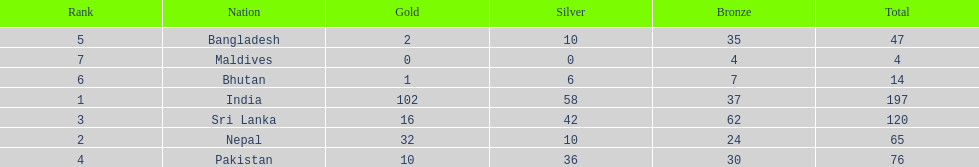Name the first country on the table? India. 